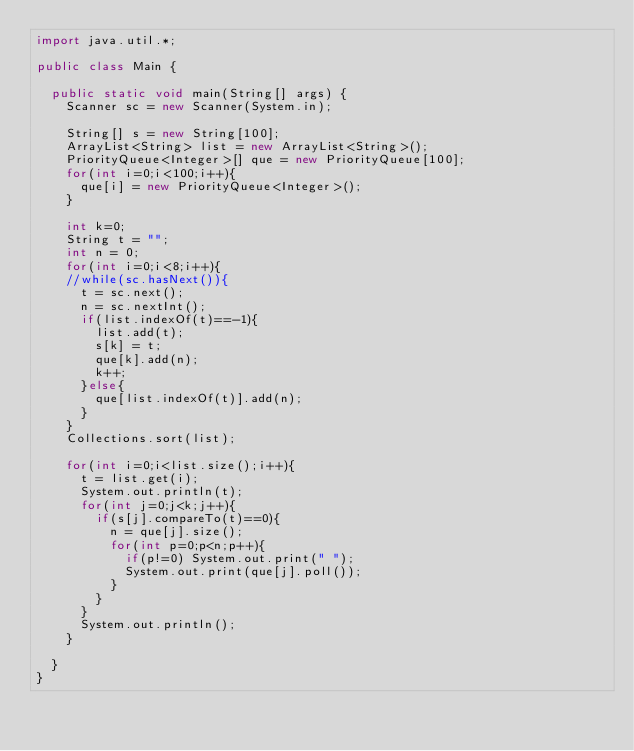Convert code to text. <code><loc_0><loc_0><loc_500><loc_500><_Java_>import java.util.*;

public class Main {
	
	public static void main(String[] args) {
		Scanner sc = new Scanner(System.in);
		
		String[] s = new String[100];
		ArrayList<String> list = new ArrayList<String>();
		PriorityQueue<Integer>[] que = new PriorityQueue[100];
		for(int i=0;i<100;i++){
			que[i] = new PriorityQueue<Integer>();
		}
		
		int k=0;
		String t = "";
		int n = 0;
		for(int i=0;i<8;i++){
		//while(sc.hasNext()){
			t = sc.next();
			n = sc.nextInt();
			if(list.indexOf(t)==-1){
				list.add(t);
				s[k] = t;
				que[k].add(n);
				k++;
			}else{
				que[list.indexOf(t)].add(n);
			}
		}
		Collections.sort(list);
		
		for(int i=0;i<list.size();i++){
			t = list.get(i);
			System.out.println(t);
			for(int j=0;j<k;j++){
				if(s[j].compareTo(t)==0){
					n = que[j].size();
					for(int p=0;p<n;p++){
						if(p!=0) System.out.print(" ");
						System.out.print(que[j].poll());
					}	
				}
			}
			System.out.println();
		}
	
	}	
}</code> 